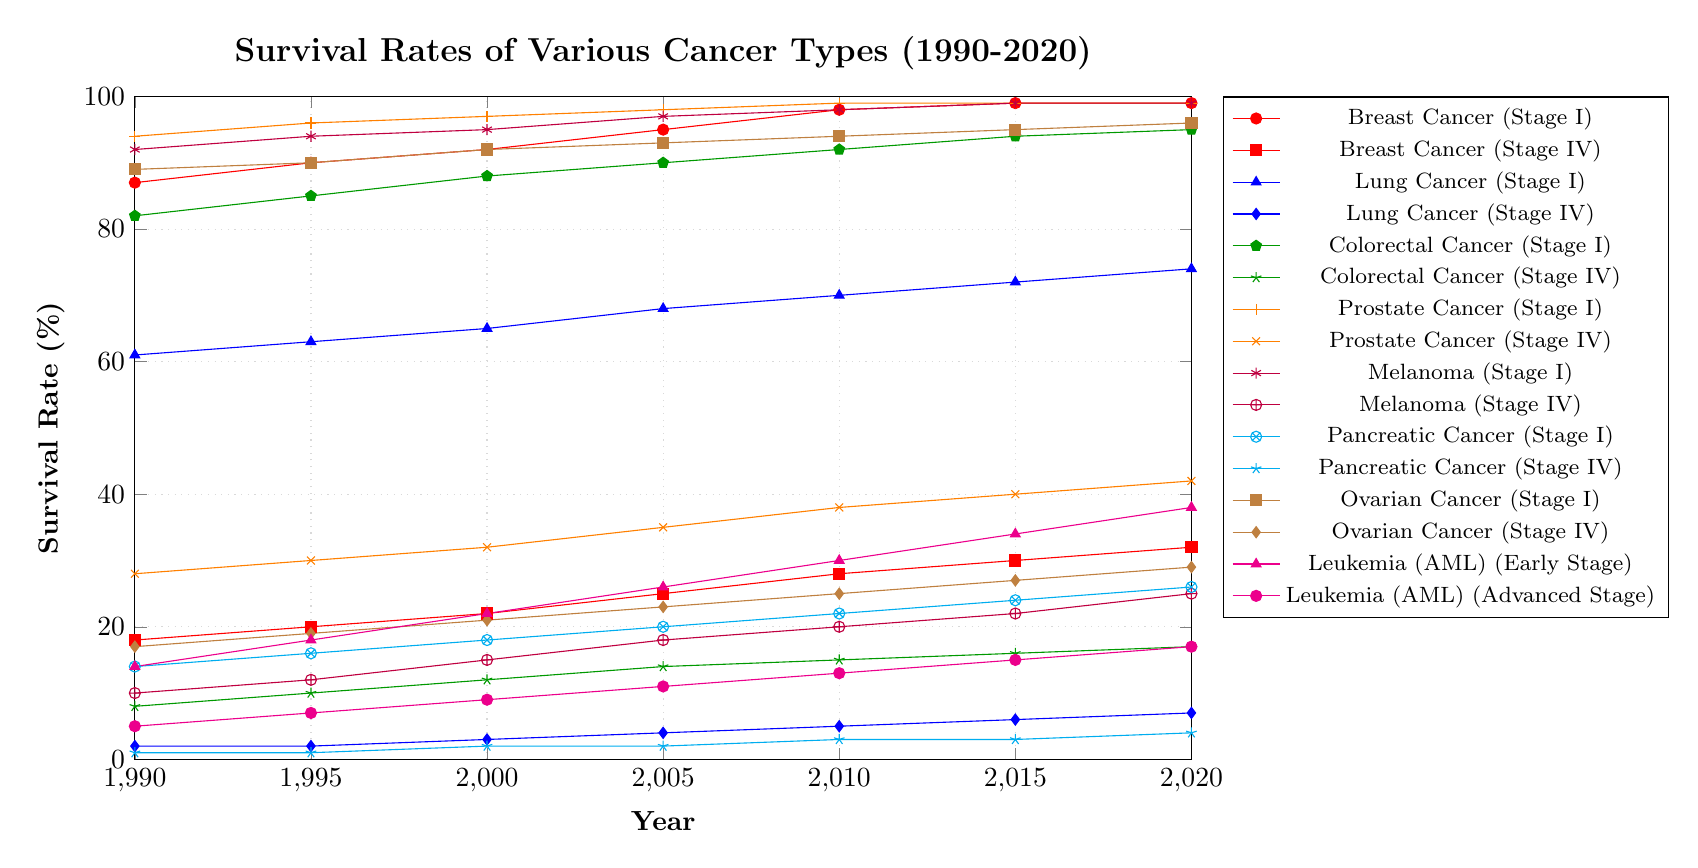Which cancer type has the highest survival rate for Stage I in 2020? The figure shows the survival rates for various cancer types. For Stage I in 2020, Breast Cancer, Prostate Cancer, Melanoma, and Ovarian Cancer all have close to 99% survival rates.
Answer: Breast Cancer, Prostate Cancer, Melanoma, Ovarian Cancer What is the trend of survival rates for Lung Cancer Stage IV from 1990 to 2020? The visual data depicts a steady upward trend for Lung Cancer Stage IV survival rates from 2% in 1990 to 7% in 2020. The increase is gradual over the decade intervals.
Answer: Increasing trend Which stage shows a greater improvement in survival rate for Colorectal Cancer from 1990 to 2020? Colorectal Cancer Stage I improved from 82% to 95% (13% increase), while Stage IV improved from 8% to 17% (9% increase).
Answer: Stage I How does the survival rate of Pancreatic Cancer Stage IV in 2020 compare to that in 1990? Pancreatic Cancer Stage IV had a survival rate of 1% in 1990 and it increased to 4% in 2020. The increase is from a very low base starting point.
Answer: Higher in 2020 What is the difference between the survival rates of AML Leukemia in early stage and advanced stage in 2020? For AML Leukemia, in 2020, early stage had a survival rate of 38%, while advanced stage had 17%. The difference is 38% - 17%.
Answer: 21% Which cancer type shows the least improvement in survival rates for Stage IV? Pancreatic Cancer Stage IV started at 1% in 1990 and reached only 4% in 2020, which is an increase of just 3%.
Answer: Pancreatic Cancer How do the trends of survival rates for Breast Cancer Stage I and Stage IV differ over the 30-year span? Breast Cancer Stage I increased significantly from 87% to 99%. Stage IV also improved but at a modest rate from 18% to 32%. Stage I shows a steeper and more significant rise compared to Stage IV.
Answer: Stage I improves more significantly What is the average survival rate of Leukemia (AML) Early Stage across all years presented? Sum the survival rates: 14+18+22+26+30+34+38 = 182. There are 7 years, so the average is 182/7.
Answer: 26% Compare the survival rates of Melanoma (Stage I) and Ovarian Cancer (Stage I) in 2010. Which is higher? In 2010, the survival rate for Melanoma (Stage I) was 98%, and for Ovarian Cancer (Stage I) it was 94%.
Answer: Melanoma What is the visual difference in the trend lines of Prostate Cancer Stage I and Pancreatic Cancer Stage IV? Prostate Cancer Stage I shows a high initial rate that remains consistent near 99%, whereas Pancreatic Cancer Stage IV starts extremely low at 1% and increases marginally to 4%, indicating a slow upward trend.
Answer: Steady high vs. low gradual increase 